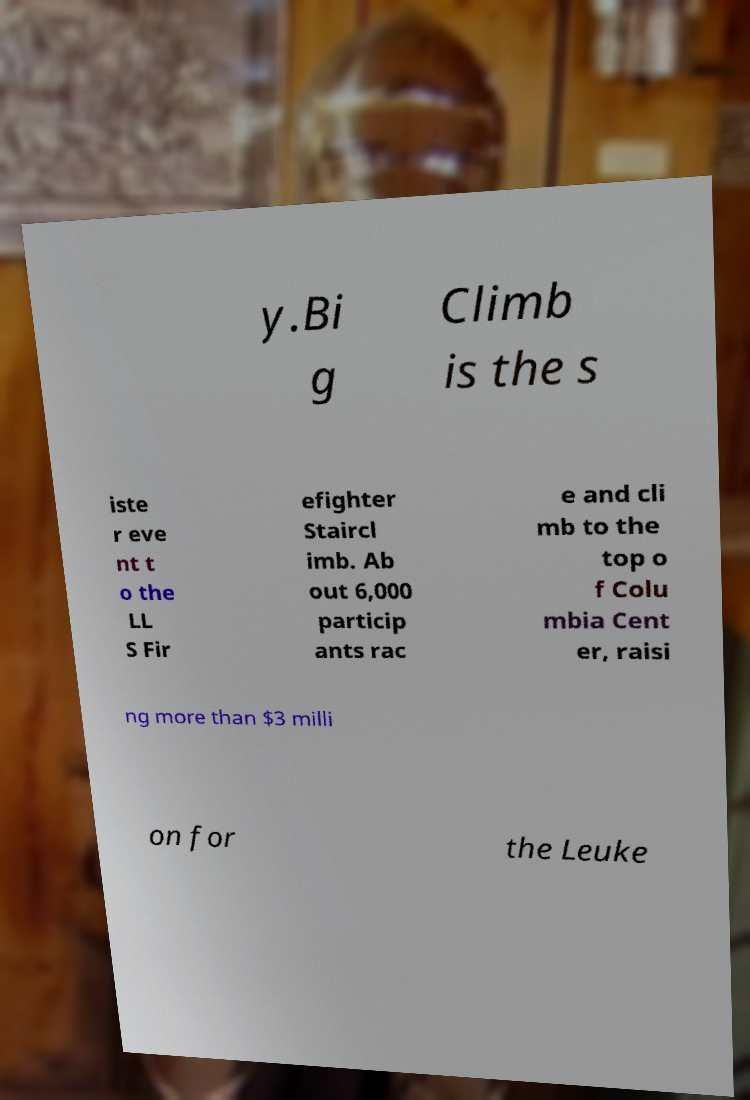Please read and relay the text visible in this image. What does it say? y.Bi g Climb is the s iste r eve nt t o the LL S Fir efighter Staircl imb. Ab out 6,000 particip ants rac e and cli mb to the top o f Colu mbia Cent er, raisi ng more than $3 milli on for the Leuke 